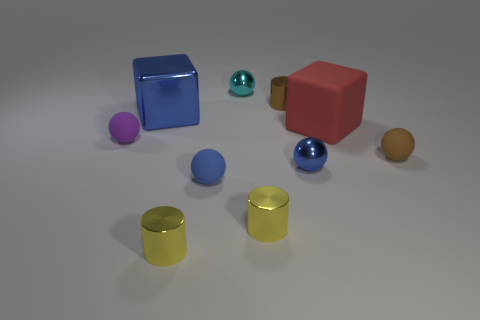Is there anything else that has the same shape as the small cyan thing?
Offer a very short reply. Yes. Is there anything else that has the same size as the brown matte thing?
Give a very brief answer. Yes. What color is the big cube that is made of the same material as the brown cylinder?
Your answer should be very brief. Blue. There is a tiny rubber sphere in front of the small brown rubber thing; what is its color?
Your answer should be compact. Blue. What number of matte spheres are the same color as the metallic cube?
Keep it short and to the point. 1. Is the number of cyan metallic spheres that are to the right of the big matte thing less than the number of big matte blocks to the left of the metal block?
Offer a terse response. No. There is a small purple thing; how many tiny blue matte things are behind it?
Your answer should be compact. 0. Is there a blue object that has the same material as the purple object?
Your answer should be compact. Yes. Is the number of blue shiny balls that are on the left side of the purple rubber sphere greater than the number of tiny objects on the left side of the brown sphere?
Make the answer very short. No. What is the size of the cyan metal sphere?
Your response must be concise. Small. 